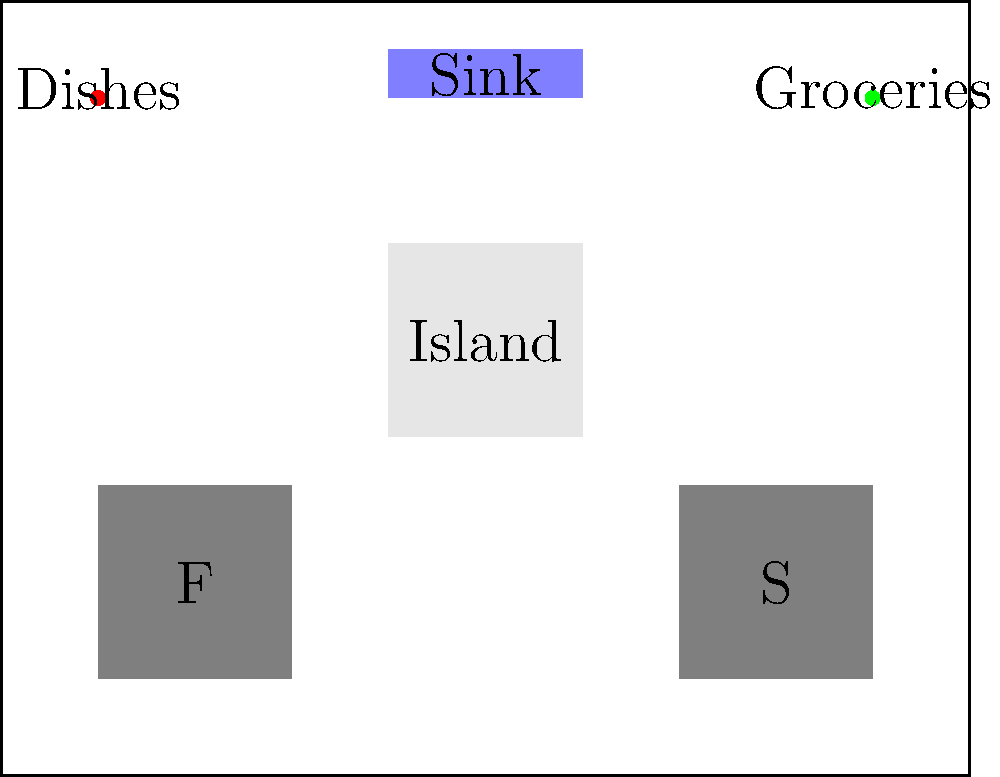In a modern kitchen designed to challenge traditional gender roles, you need to optimize the placement of dishes and groceries. The kitchen layout is shown above, with F representing the fridge, S the stove, and other key elements labeled. If the goal is to minimize the total distance traveled while promoting equal participation in household tasks, where should the dishes and groceries be placed? To solve this problem, we need to consider the following steps:

1. Analyze the current layout:
   - Dishes are currently near the top left corner
   - Groceries are currently near the top right corner
   - The sink is centrally located at the top
   - The island is in the center
   - The fridge (F) is in the bottom left
   - The stove (S) is in the bottom right

2. Consider the typical workflow:
   - Groceries need to be unpacked and stored in the fridge or cabinets
   - Dishes need to be washed in the sink and then stored

3. Evaluate the distances:
   - Current dish placement requires a long distance to the sink
   - Current grocery placement is far from the fridge

4. Optimize for efficiency and equal participation:
   - Placing dishes closer to the sink reduces the distance for washing
   - Placing groceries closer to the fridge reduces unpacking distance
   - Centralizing both items promotes shared responsibility

5. Propose a solution:
   - Move both dishes and groceries to the island in the center
   - This location is equidistant from the sink and fridge
   - It's accessible from all sides, encouraging shared tasks

6. Benefits of the proposed solution:
   - Reduced total distance traveled for both tasks
   - Central location promotes equal access and shared responsibility
   - Challenges traditional gender-specific roles in the kitchen

By placing both the dishes and groceries on the central island, we create an efficient and egalitarian kitchen layout that encourages equal participation in household tasks.
Answer: Place dishes and groceries on the central island. 